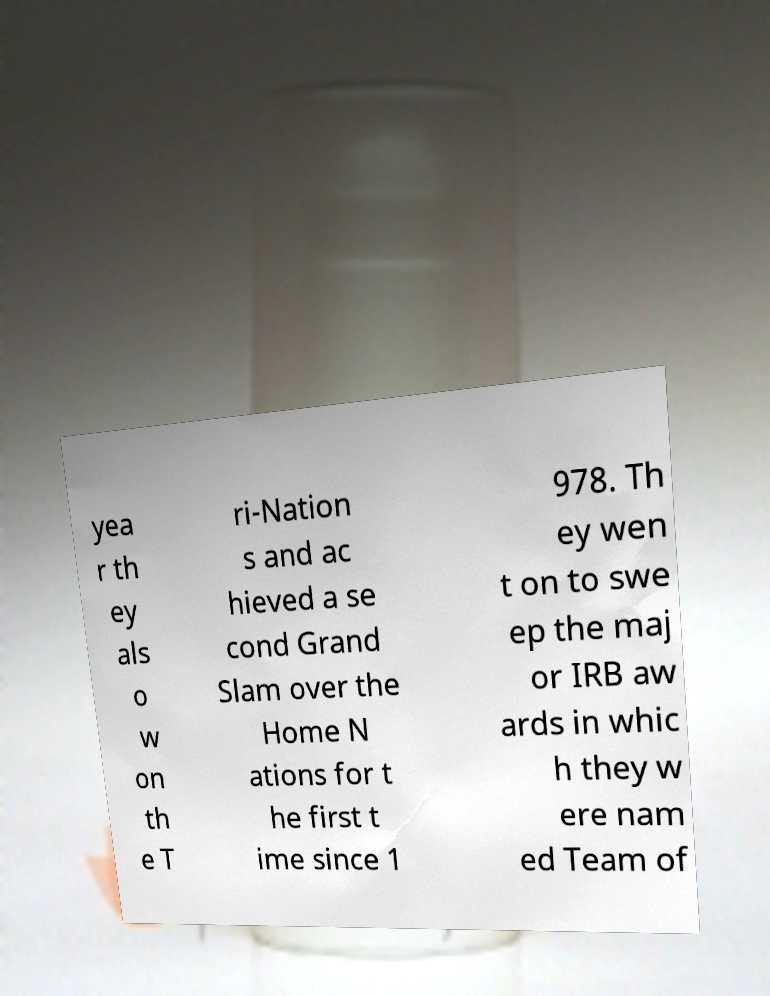Please identify and transcribe the text found in this image. yea r th ey als o w on th e T ri-Nation s and ac hieved a se cond Grand Slam over the Home N ations for t he first t ime since 1 978. Th ey wen t on to swe ep the maj or IRB aw ards in whic h they w ere nam ed Team of 